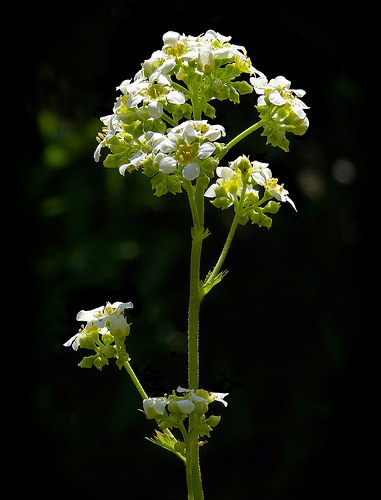<image>
Is there a petal above the pollen? Yes. The petal is positioned above the pollen in the vertical space, higher up in the scene. 